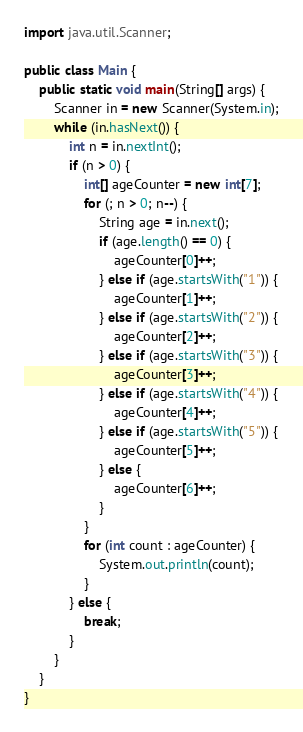<code> <loc_0><loc_0><loc_500><loc_500><_Java_>import java.util.Scanner;

public class Main {
	public static void main(String[] args) {
		Scanner in = new Scanner(System.in);
		while (in.hasNext()) {
			int n = in.nextInt();
			if (n > 0) {
				int[] ageCounter = new int[7];
				for (; n > 0; n--) {
					String age = in.next();
					if (age.length() == 0) {
						ageCounter[0]++;
					} else if (age.startsWith("1")) {
						ageCounter[1]++;
					} else if (age.startsWith("2")) {
						ageCounter[2]++;
					} else if (age.startsWith("3")) {
						ageCounter[3]++;
					} else if (age.startsWith("4")) {
						ageCounter[4]++;
					} else if (age.startsWith("5")) {
						ageCounter[5]++;
					} else {
						ageCounter[6]++;
					}
				}
				for (int count : ageCounter) {
					System.out.println(count);
				}
			} else {
				break;
			}
		}
	}
}</code> 